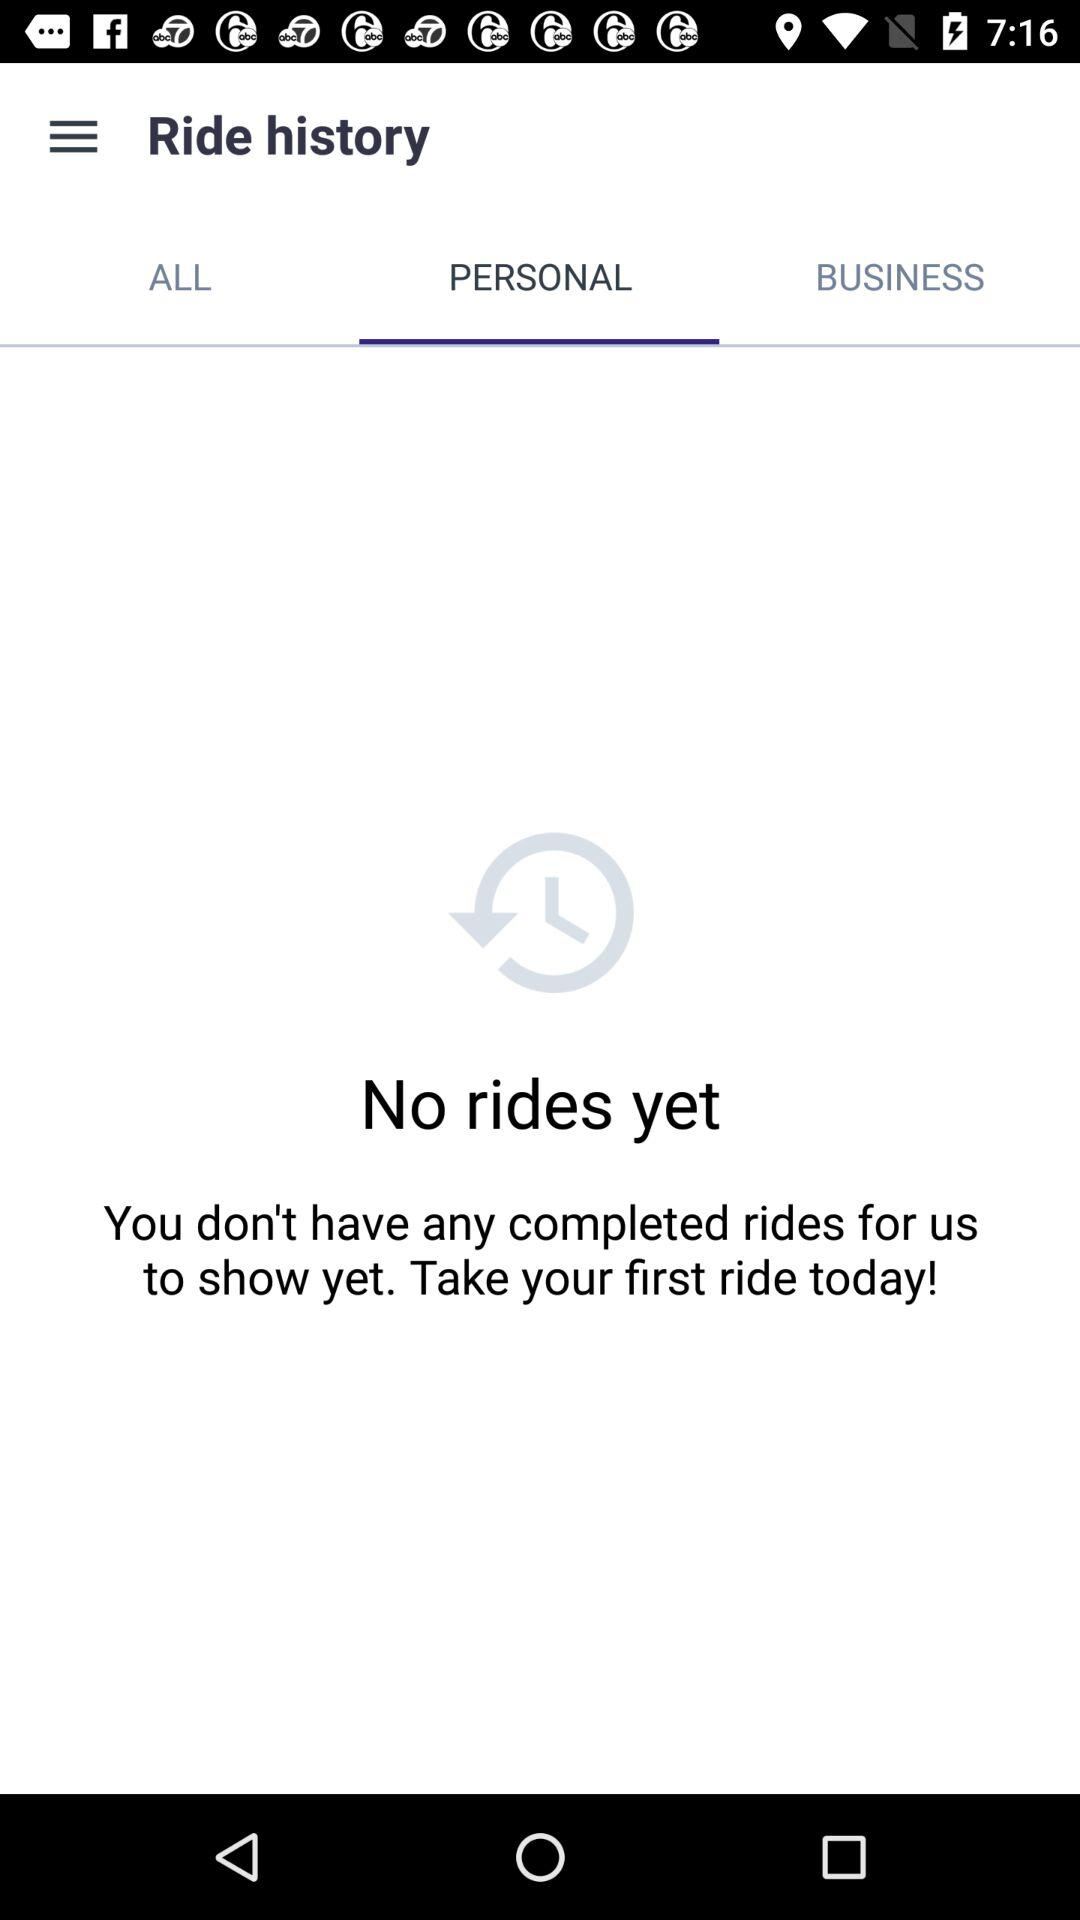How many rides are completed? There are no completed rides. 